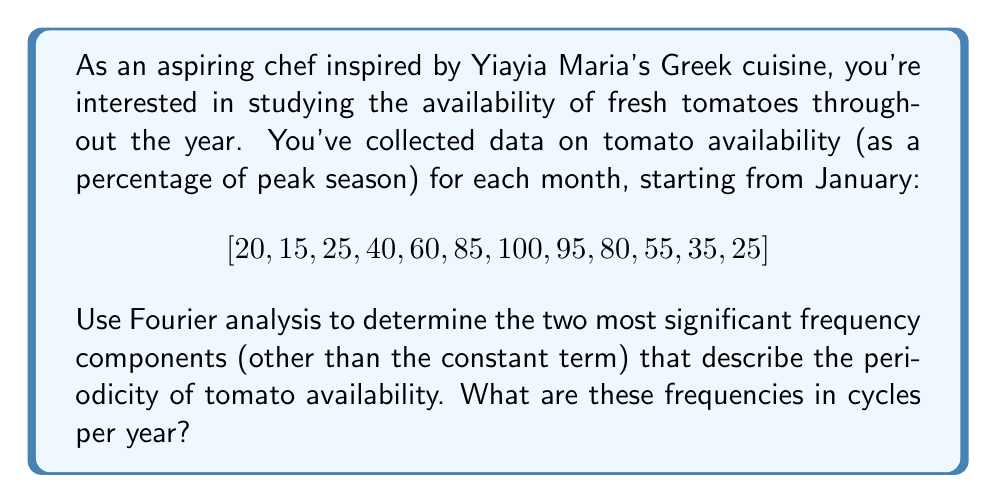Can you answer this question? To solve this problem using Fourier analysis, we'll follow these steps:

1) First, we need to compute the Discrete Fourier Transform (DFT) of our data. For a sequence $x_n$ of length $N$, the DFT is given by:

   $$X_k = \sum_{n=0}^{N-1} x_n e^{-2\pi i kn/N}$$

   where $k = 0, 1, ..., N-1$

2) In our case, $N = 12$ (12 months of data). Let's compute $X_k$ for $k = 0, 1, ..., 11$:

   $X_0 = 635$ (this is just the sum of all data points)
   $X_1 = -168.17 - 193.67i$
   $X_2 = -65.98 + 114.31i$
   $X_3 = 52.5 + 91.03i$
   $X_4 = 35 - 60.62i$
   $X_5 = -16.83 - 29.15i$
   $X_6 = -37.5$
   $X_7 = -16.83 + 29.15i$
   $X_8 = 35 + 60.62i$
   $X_9 = 52.5 - 91.03i$
   $X_{10} = -65.98 - 114.31i$
   $X_{11} = -168.17 + 193.67i$

3) The magnitude of each $X_k$ represents the strength of the frequency component:

   $|X_0| = 635$
   $|X_1| = |X_{11}| = 256.35$
   $|X_2| = |X_{10}| = 131.84$
   $|X_3| = |X_9| = 105.15$
   $|X_4| = |X_8| = 70.00$
   $|X_5| = |X_7| = 33.66$
   $|X_6| = 37.5$

4) Excluding $X_0$ (which represents the constant term), the two largest magnitudes correspond to $X_1$ (and $X_{11}$) and $X_2$ (and $X_{10}$).

5) These frequencies correspond to:
   - 1 cycle per year (for $X_1$ and $X_{11}$)
   - 2 cycles per year (for $X_2$ and $X_{10}$)

Therefore, the two most significant frequency components are 1 cycle per year and 2 cycles per year.
Answer: The two most significant frequency components are 1 cycle per year and 2 cycles per year. 